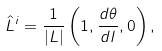Convert formula to latex. <formula><loc_0><loc_0><loc_500><loc_500>\hat { L } ^ { i } = \frac { 1 } { | L | } \left ( 1 , \frac { d \theta } { d l } , 0 \right ) ,</formula> 